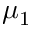<formula> <loc_0><loc_0><loc_500><loc_500>\mu _ { 1 }</formula> 